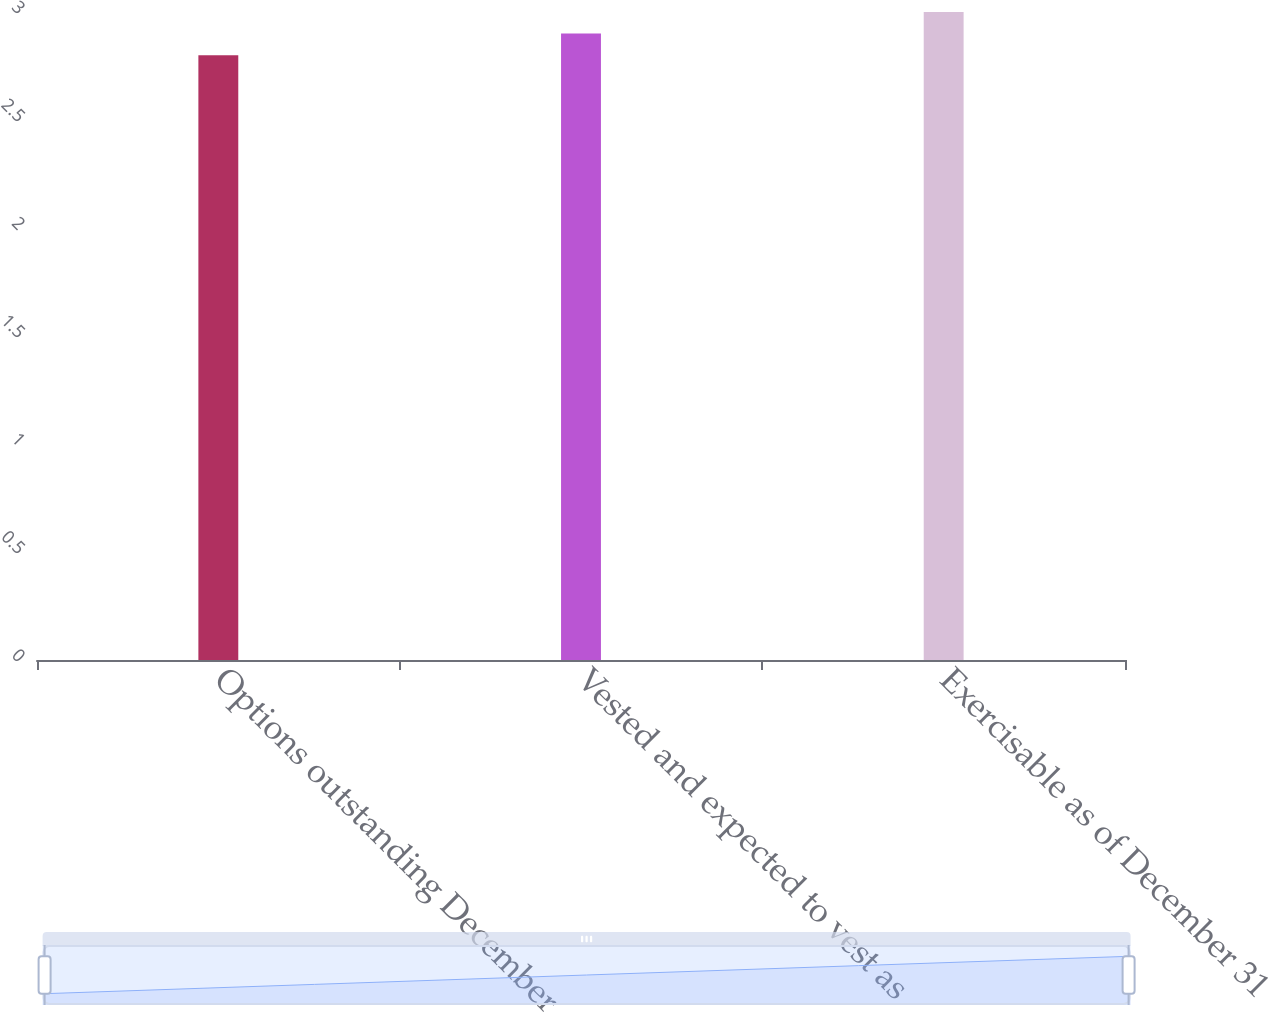<chart> <loc_0><loc_0><loc_500><loc_500><bar_chart><fcel>Options outstanding December<fcel>Vested and expected to vest as<fcel>Exercisable as of December 31<nl><fcel>2.8<fcel>2.9<fcel>3<nl></chart> 